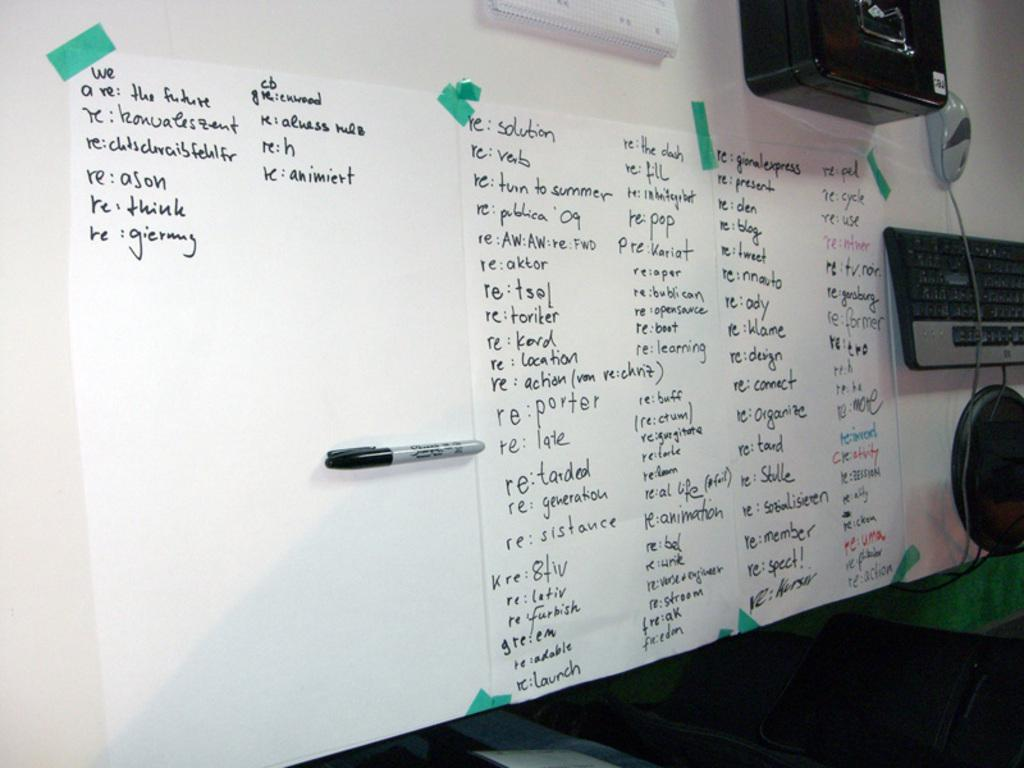Provide a one-sentence caption for the provided image. An white board with paper taped to it holding a large piece of paper with the first sentenec saying, "We are the future.". 